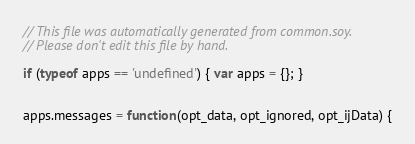Convert code to text. <code><loc_0><loc_0><loc_500><loc_500><_JavaScript_>// This file was automatically generated from common.soy.
// Please don't edit this file by hand.

if (typeof apps == 'undefined') { var apps = {}; }


apps.messages = function(opt_data, opt_ignored, opt_ijData) {</code> 